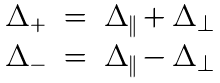<formula> <loc_0><loc_0><loc_500><loc_500>\begin{array} { r c l } \Delta _ { + } & = & \Delta _ { \| } + \Delta _ { \perp } \\ \Delta _ { - } & = & \Delta _ { \| } - \Delta _ { \perp } \end{array}</formula> 